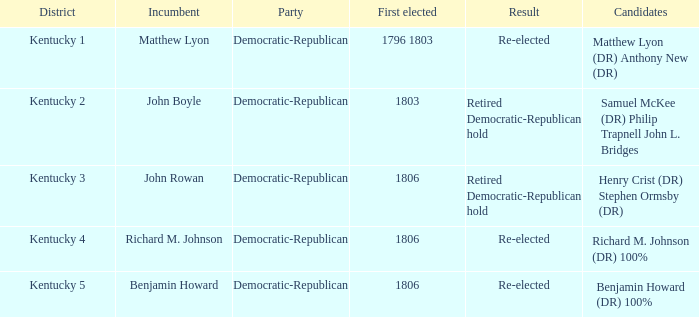Who was the first person elected for kentucky's 3rd district? 1806.0. 